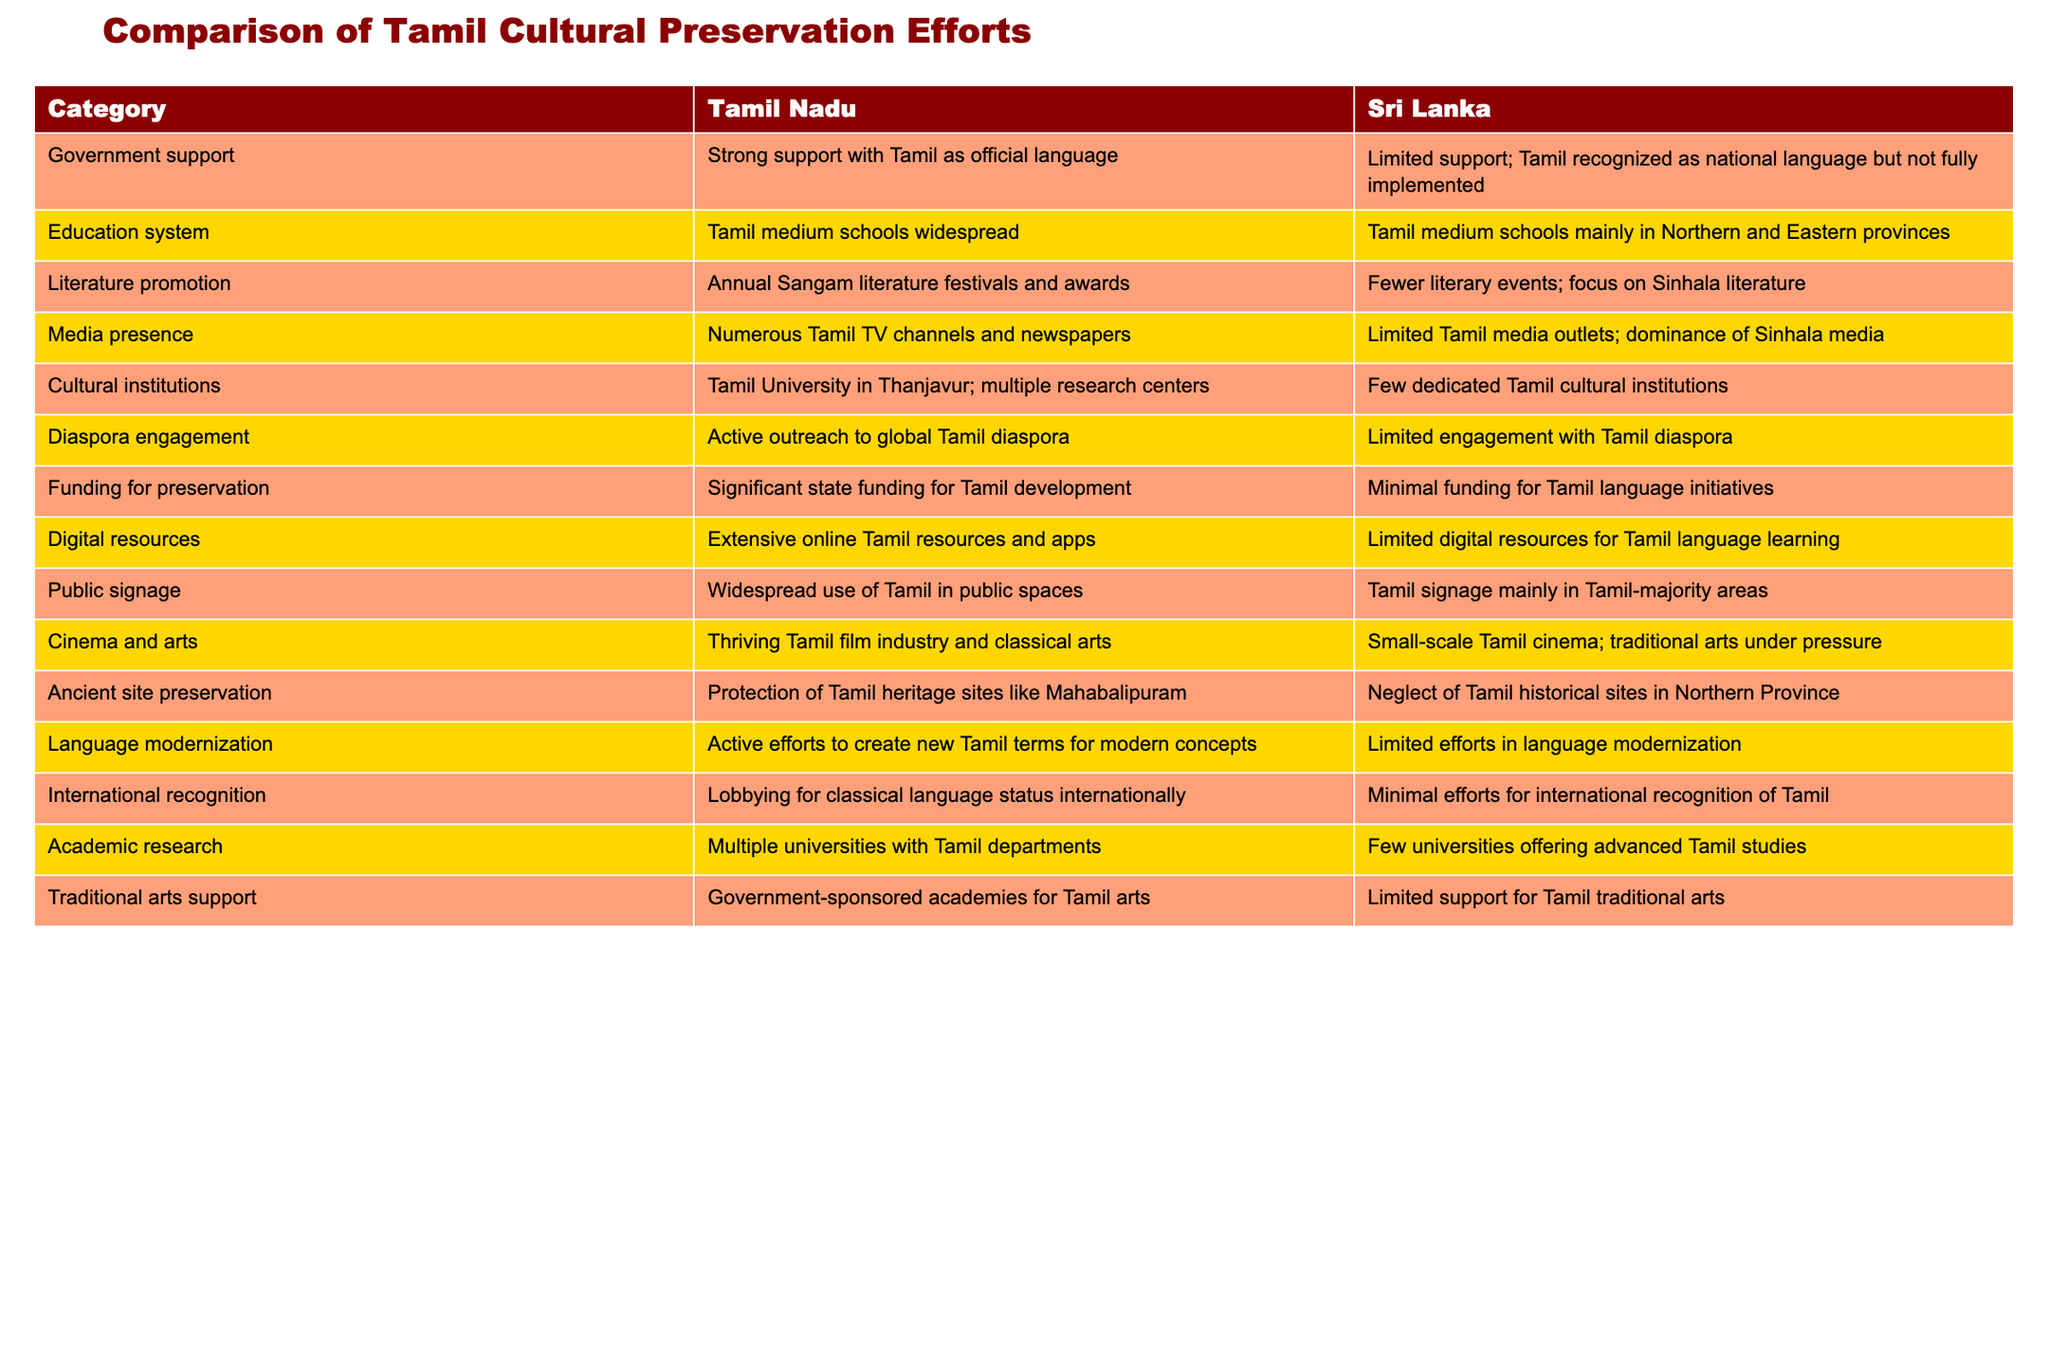What category has strong government support in Tamil Nadu? The table shows that Tamil Nadu has "Strong support with Tamil as official language" under the Government support category.
Answer: Strong support with Tamil as official language How many Tamil medium schools are widespread in Tamil Nadu compared to Sri Lanka? The table indicates that Tamil medium schools are widespread in Tamil Nadu, while in Sri Lanka, these schools are mainly located in the Northern and Eastern provinces, suggesting a stark contrast.
Answer: Widespread in Tamil Nadu; limited in Sri Lanka Is there significant funding for Tamil language initiatives in Sri Lanka? The data states that there is minimal funding for Tamil language initiatives in Sri Lanka, indicating a lack of support compared to Tamil Nadu's significant state funding.
Answer: No What is the difference in literature promotion between Tamil Nadu and Sri Lanka? Tamil Nadu hosts annual literature festivals and awards, while Sri Lanka has fewer literary events that focus on Sinhala literature. This indicates Tamil Nadu's proactive role in promoting Tamil literature compared to Sri Lanka.
Answer: Tamil Nadu actively promotes literature; Sri Lanka focuses on Sinhala literature Which category shows minimal engagement with the Tamil diaspora in Sri Lanka? The table specifies that Sri Lanka has limited engagement with the Tamil diaspora, while Tamil Nadu has active outreach efforts. This highlights a significant gap in diaspora engagement between the two regions.
Answer: Limited engagement in Sri Lanka How many cultural institutions are there in Tamil Nadu compared to Sri Lanka? Tamil Nadu has a dedicated Tamil University in Thanjavur and multiple research centers, whereas Sri Lanka has few dedicated Tamil cultural institutions, showing a clear disparity in the number of cultural institutions.
Answer: More in Tamil Nadu Is there a thriving Tamil film industry in Sri Lanka? The table shows that Tamil Nadu has a thriving Tamil film industry while Sri Lanka has only a small-scale Tamil cinema, indicating that Sri Lanka does not have a similar level of film industry development.
Answer: No How do digital resources for Tamil language learning compare between Tamil Nadu and Sri Lanka? The table indicates that Tamil Nadu has extensive online Tamil resources and apps, whereas Sri Lanka has limited digital resources for Tamil language learning, highlighting a significant difference in digital support.
Answer: Tamil Nadu has extensive resources; Sri Lanka has limited resources What is the overall trend in language modernization efforts between Tamil Nadu and Sri Lanka? The data shows that Tamil Nadu has active efforts to create new Tamil terms for modern concepts, while Sri Lanka has limited efforts in language modernization, indicating Tamil Nadu's proactive stance in this area.
Answer: More effort in Tamil Nadu 